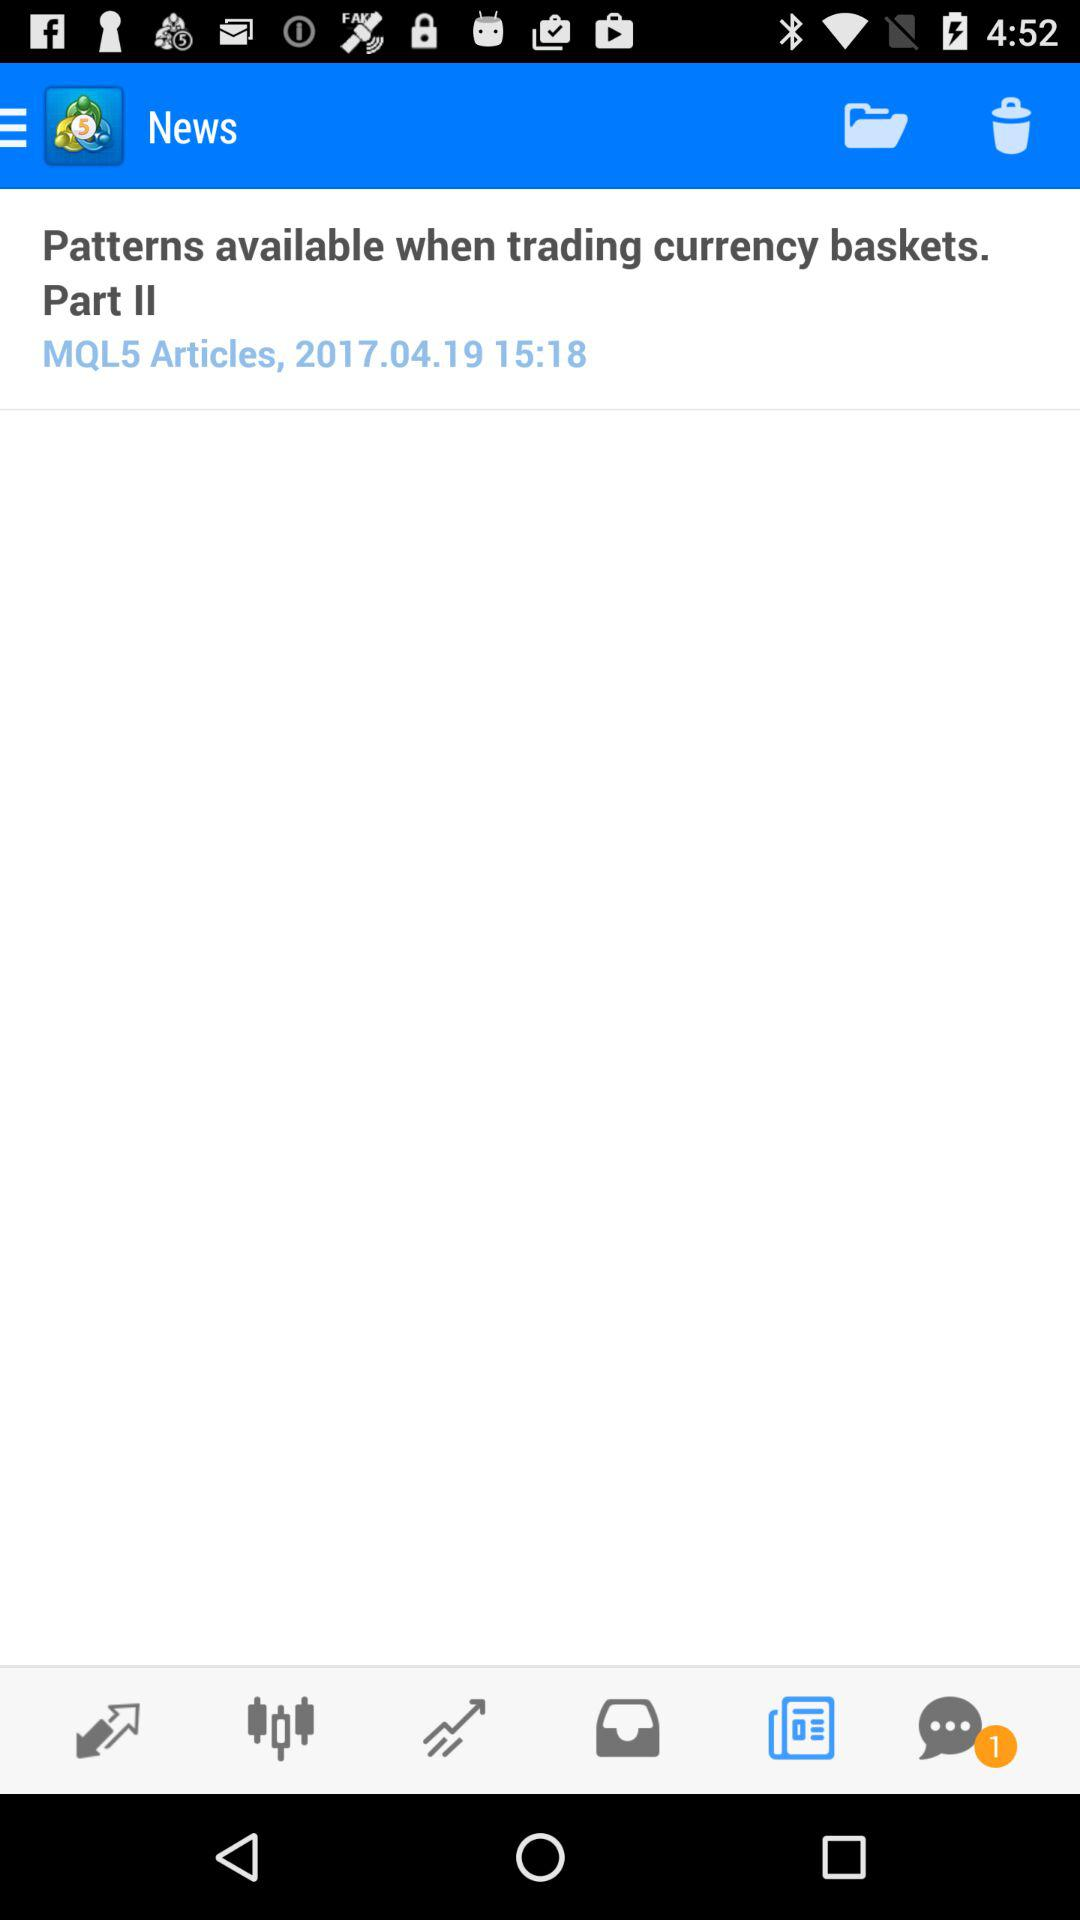At what time was the article posted? The article was posted at 15:18. 